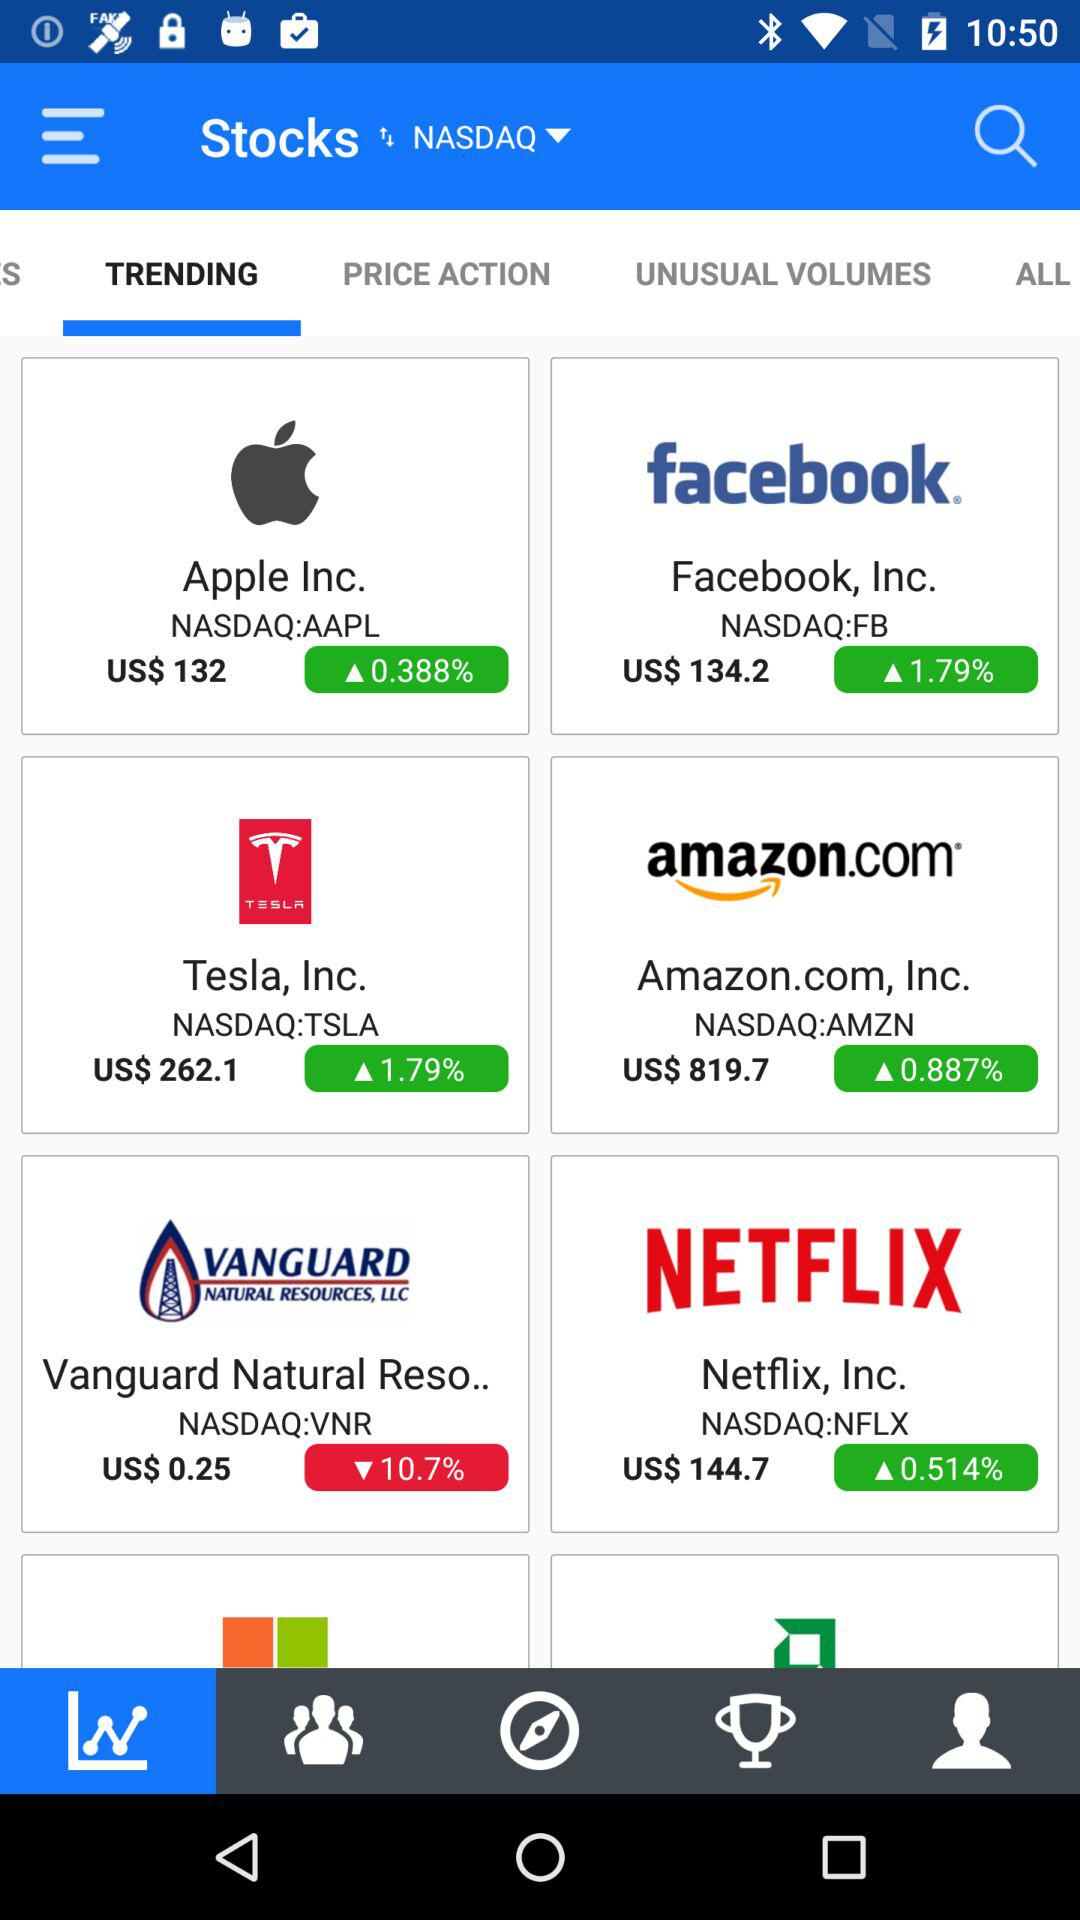What is the price of the "Tesla" stock? The price of the "Tesla" stock is US $262.1. 